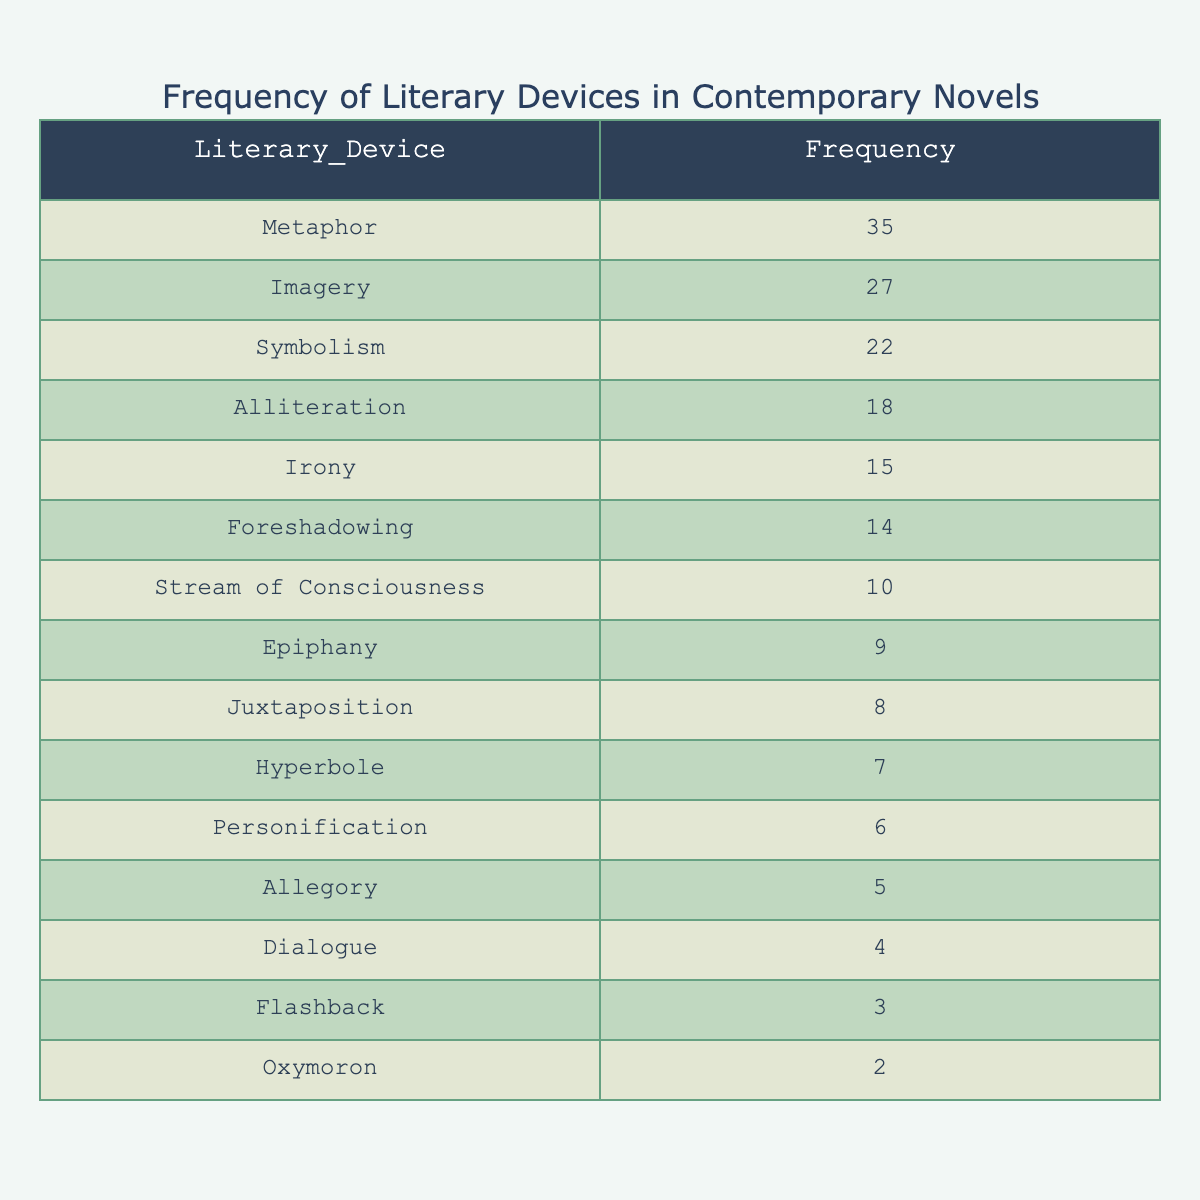What is the frequency of metaphor used in contemporary novels? The value in the table for metaphor is directly given. It states that the frequency of metaphor is 35.
Answer: 35 Which literary device has the highest frequency? By looking at the values in the table, metaphor, with a frequency of 35, is higher than all other literary devices listed.
Answer: Metaphor What is the frequency of alliteration, and how does it compare to symbolism? The frequency of alliteration is 18, while symbolism's frequency is 22. To compare, symbolism is higher than alliteration.
Answer: 18, Symbolism is higher What is the total frequency of the top three literary devices? The top three literary devices are metaphor (35), imagery (27), and symbolism (22). Adding them together: 35 + 27 + 22 = 84 gives the total frequency.
Answer: 84 Is the frequency of hyperbole greater than that of personification? The frequency of hyperbole is 7, and for personification, it is 6. Since 7 is greater than 6, the statement is true.
Answer: Yes What is the difference in frequency between foreshadowing and epiphany? The frequency of foreshadowing is 14, and for epiphany, it is 9. Subtracting these gives 14 - 9 = 5. Therefore, the difference is 5.
Answer: 5 How many literary devices have a frequency of less than 10? The devices with frequencies below 10 are stream of consciousness (10), epiphany (9), juxtaposition (8), hyperbole (7), personification (6), allegory (5), dialogue (4), flashback (3), and oxymoron (2). Counting these gives 8 such devices.
Answer: 8 What is the average frequency of the listed literary devices? To find the average, first sum the frequencies: 35 + 27 + 22 + 18 + 15 + 14 + 10 + 9 + 8 + 7 + 6 + 5 + 4 + 3 + 2 =  1,094. There are 15 devices, so 1,094 / 15 gives an average of about 73.
Answer: Approximately 73 What percentage of the total frequency is represented by irony? The frequency of irony is 15. To find the percentage, first calculate the total frequency: 1,094 (from the previous answer), then divide irony's frequency by the total: (15 / 1,094) * 100 gives about 1.37%.
Answer: Approximately 1.37% 